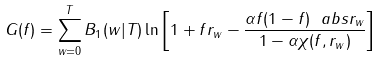<formula> <loc_0><loc_0><loc_500><loc_500>G ( f ) = \sum _ { w = 0 } ^ { T } B _ { 1 } ( w | T ) \ln \left [ 1 + f r _ { w } - \frac { \alpha f ( 1 - f ) \ a b s { r _ { w } } } { 1 - \alpha \chi ( f , r _ { w } ) } \right ]</formula> 